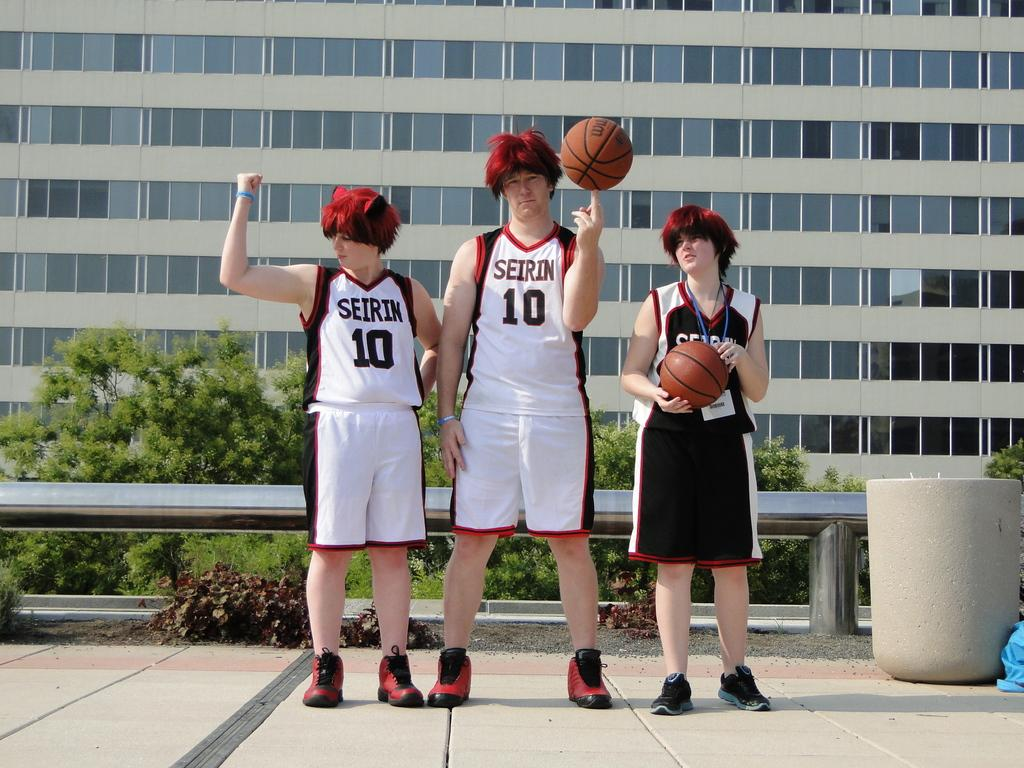<image>
Offer a succinct explanation of the picture presented. Two basketball players in red wigs wear uniforms with the number 10 on them. 